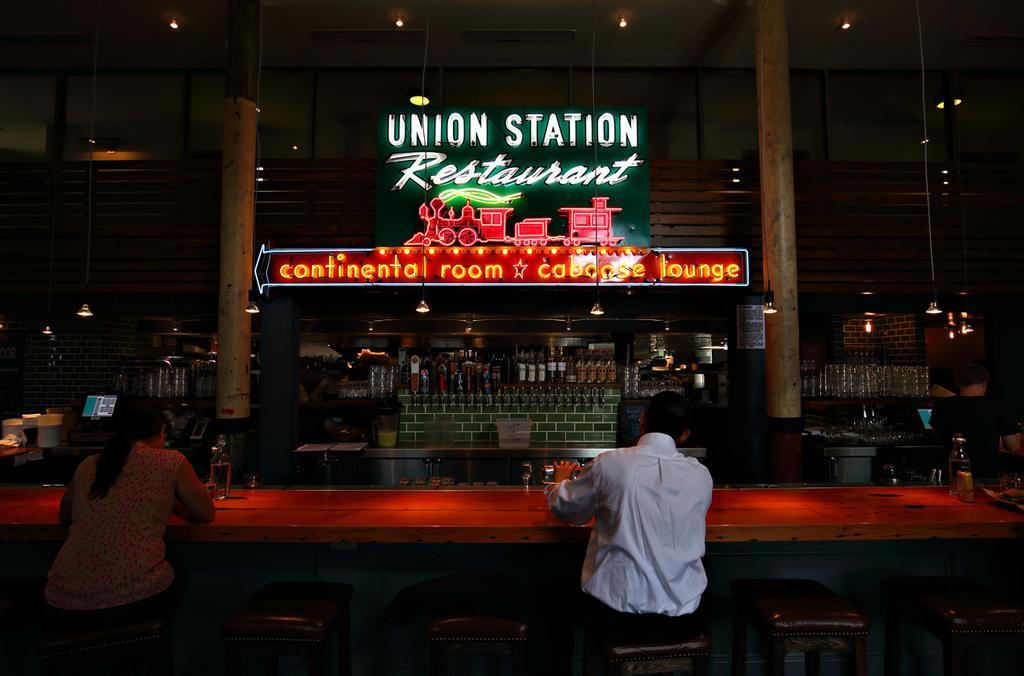Can you describe this image briefly? In this picture we can see a store, there are two persons sitting on chairs in front of a table, we can see bottles present on the table, a man on the right side is holding a bottle, in the background we can see hoarding and some bottles, on the right side and left side there are two pillars, on the left side we can see a monitor, on the right side there are some glasses, in the background we can see some lights. 